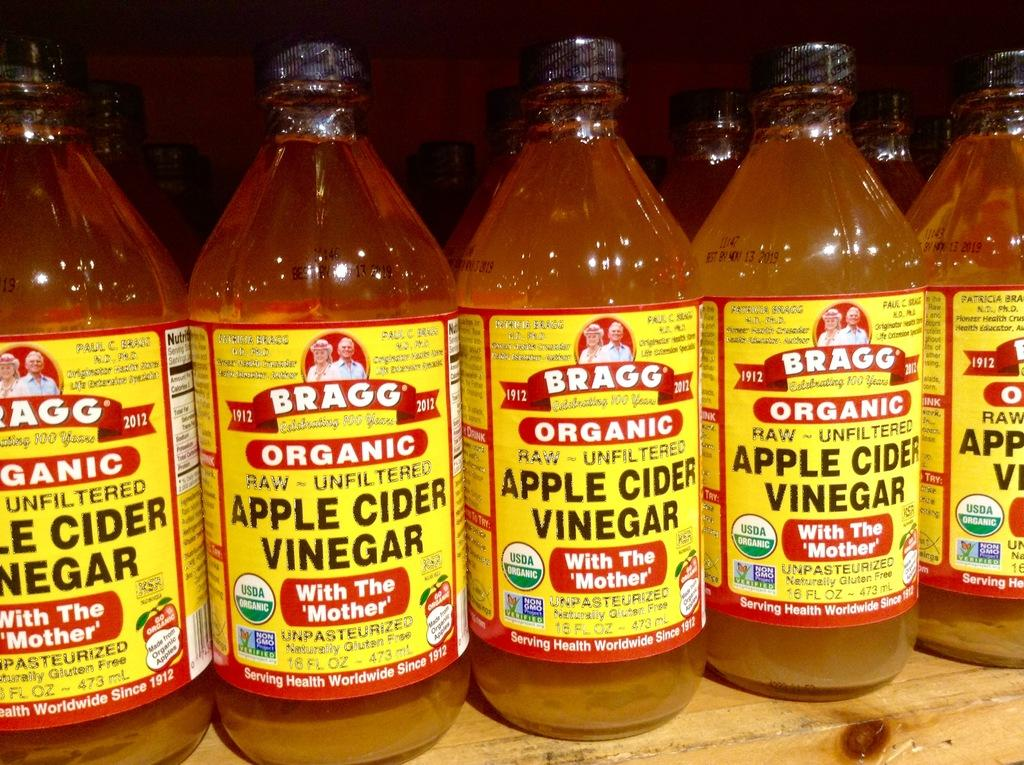<image>
Present a compact description of the photo's key features. Several bottles of Apple Cider Vinegar sit on a shelf 